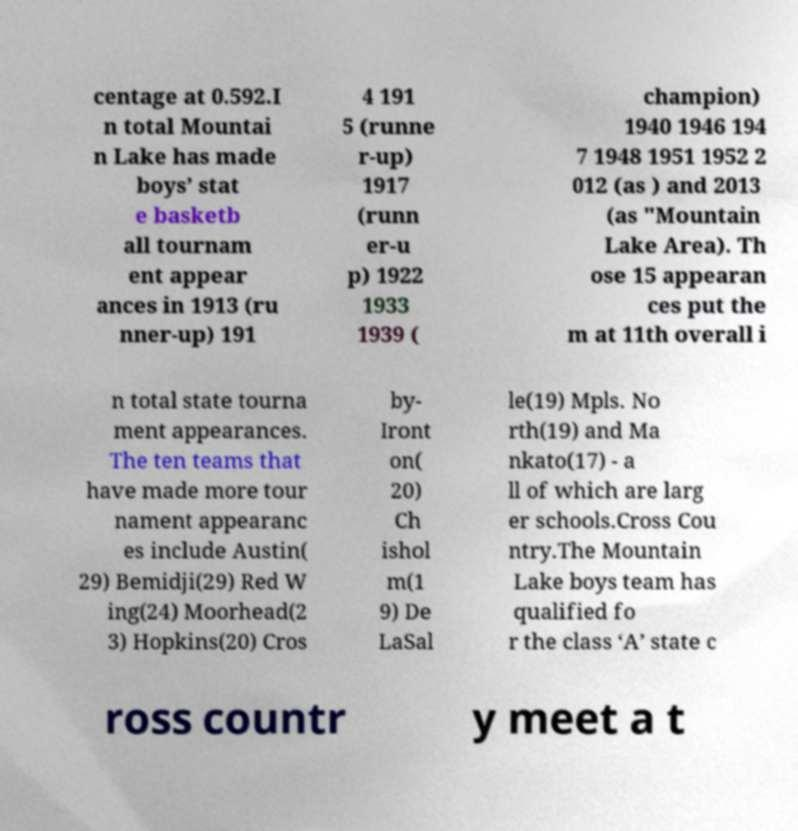What messages or text are displayed in this image? I need them in a readable, typed format. centage at 0.592.I n total Mountai n Lake has made boys’ stat e basketb all tournam ent appear ances in 1913 (ru nner-up) 191 4 191 5 (runne r-up) 1917 (runn er-u p) 1922 1933 1939 ( champion) 1940 1946 194 7 1948 1951 1952 2 012 (as ) and 2013 (as "Mountain Lake Area). Th ose 15 appearan ces put the m at 11th overall i n total state tourna ment appearances. The ten teams that have made more tour nament appearanc es include Austin( 29) Bemidji(29) Red W ing(24) Moorhead(2 3) Hopkins(20) Cros by- Iront on( 20) Ch ishol m(1 9) De LaSal le(19) Mpls. No rth(19) and Ma nkato(17) - a ll of which are larg er schools.Cross Cou ntry.The Mountain Lake boys team has qualified fo r the class ‘A’ state c ross countr y meet a t 